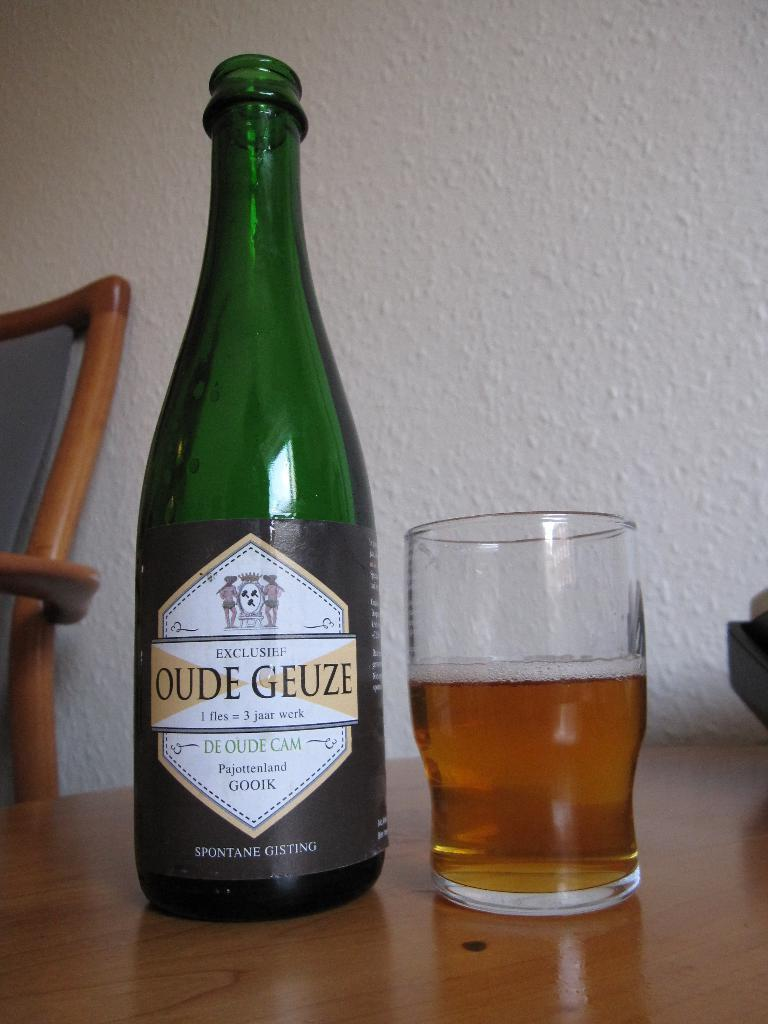<image>
Offer a succinct explanation of the picture presented. A bottle of Oude Geuzi sits next to a glass. 